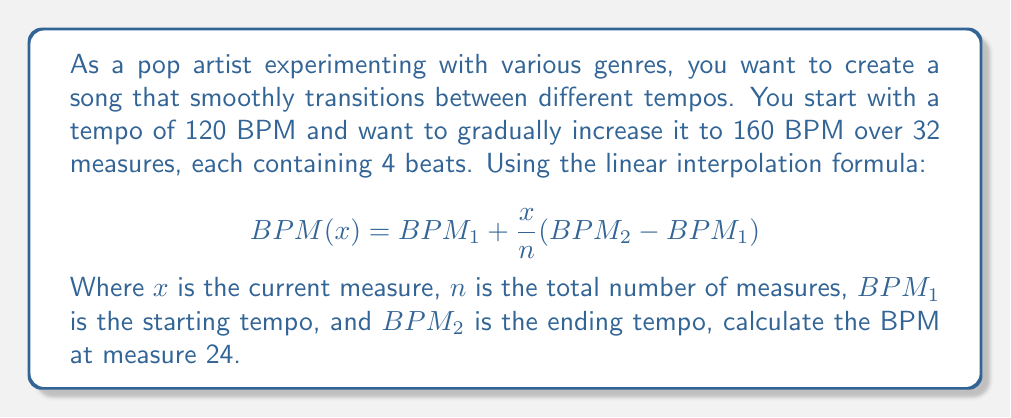Can you solve this math problem? To solve this problem, we'll follow these steps:

1. Identify the given values:
   $BPM_1 = 120$ (starting tempo)
   $BPM_2 = 160$ (ending tempo)
   $n = 32$ (total number of measures)
   $x = 24$ (current measure we're interested in)

2. Substitute these values into the linear interpolation formula:

   $$BPM(x) = BPM_1 + \frac{x}{n}(BPM_2 - BPM_1)$$

   $$BPM(24) = 120 + \frac{24}{32}(160 - 120)$$

3. Simplify the expression:
   $$BPM(24) = 120 + \frac{24}{32}(40)$$

4. Calculate the fraction:
   $$BPM(24) = 120 + \frac{3}{4}(40)$$

5. Multiply:
   $$BPM(24) = 120 + 30$$

6. Add to get the final result:
   $$BPM(24) = 150$$

Therefore, at measure 24, the tempo of the song would be 150 BPM.
Answer: 150 BPM 